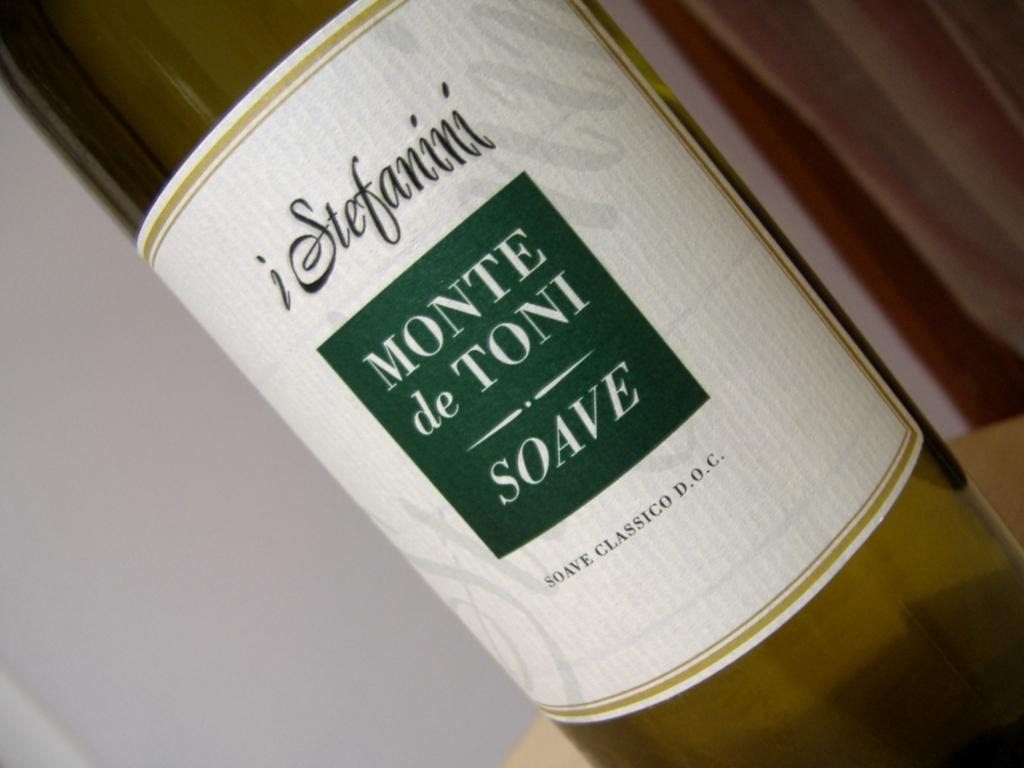Provide a one-sentence caption for the provided image. iStefanini Monte de Toni Soave Classic Wine, D.O.C. 